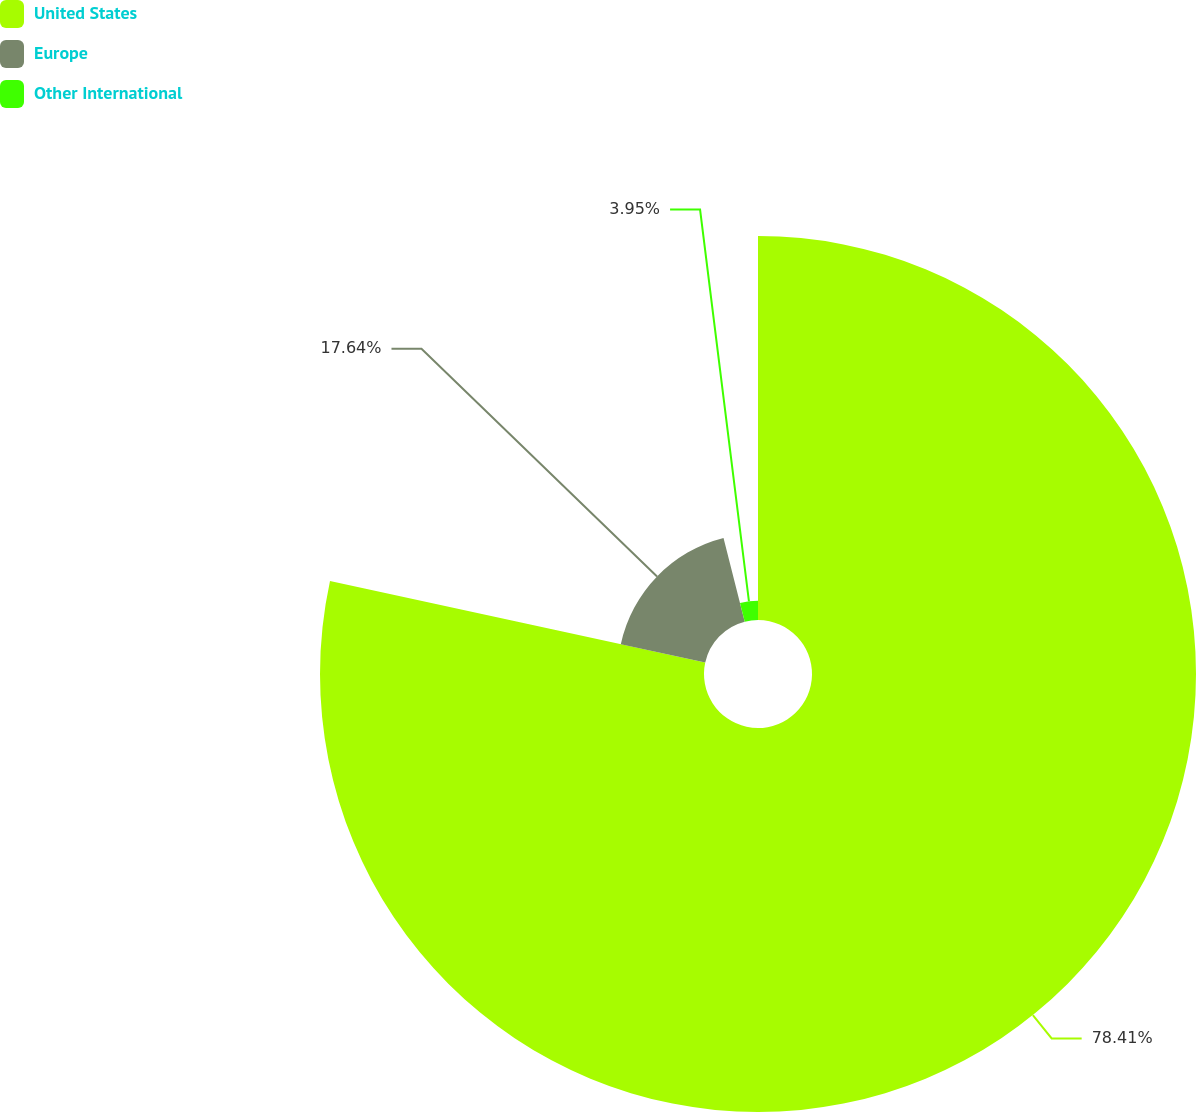Convert chart to OTSL. <chart><loc_0><loc_0><loc_500><loc_500><pie_chart><fcel>United States<fcel>Europe<fcel>Other International<nl><fcel>78.4%<fcel>17.64%<fcel>3.95%<nl></chart> 